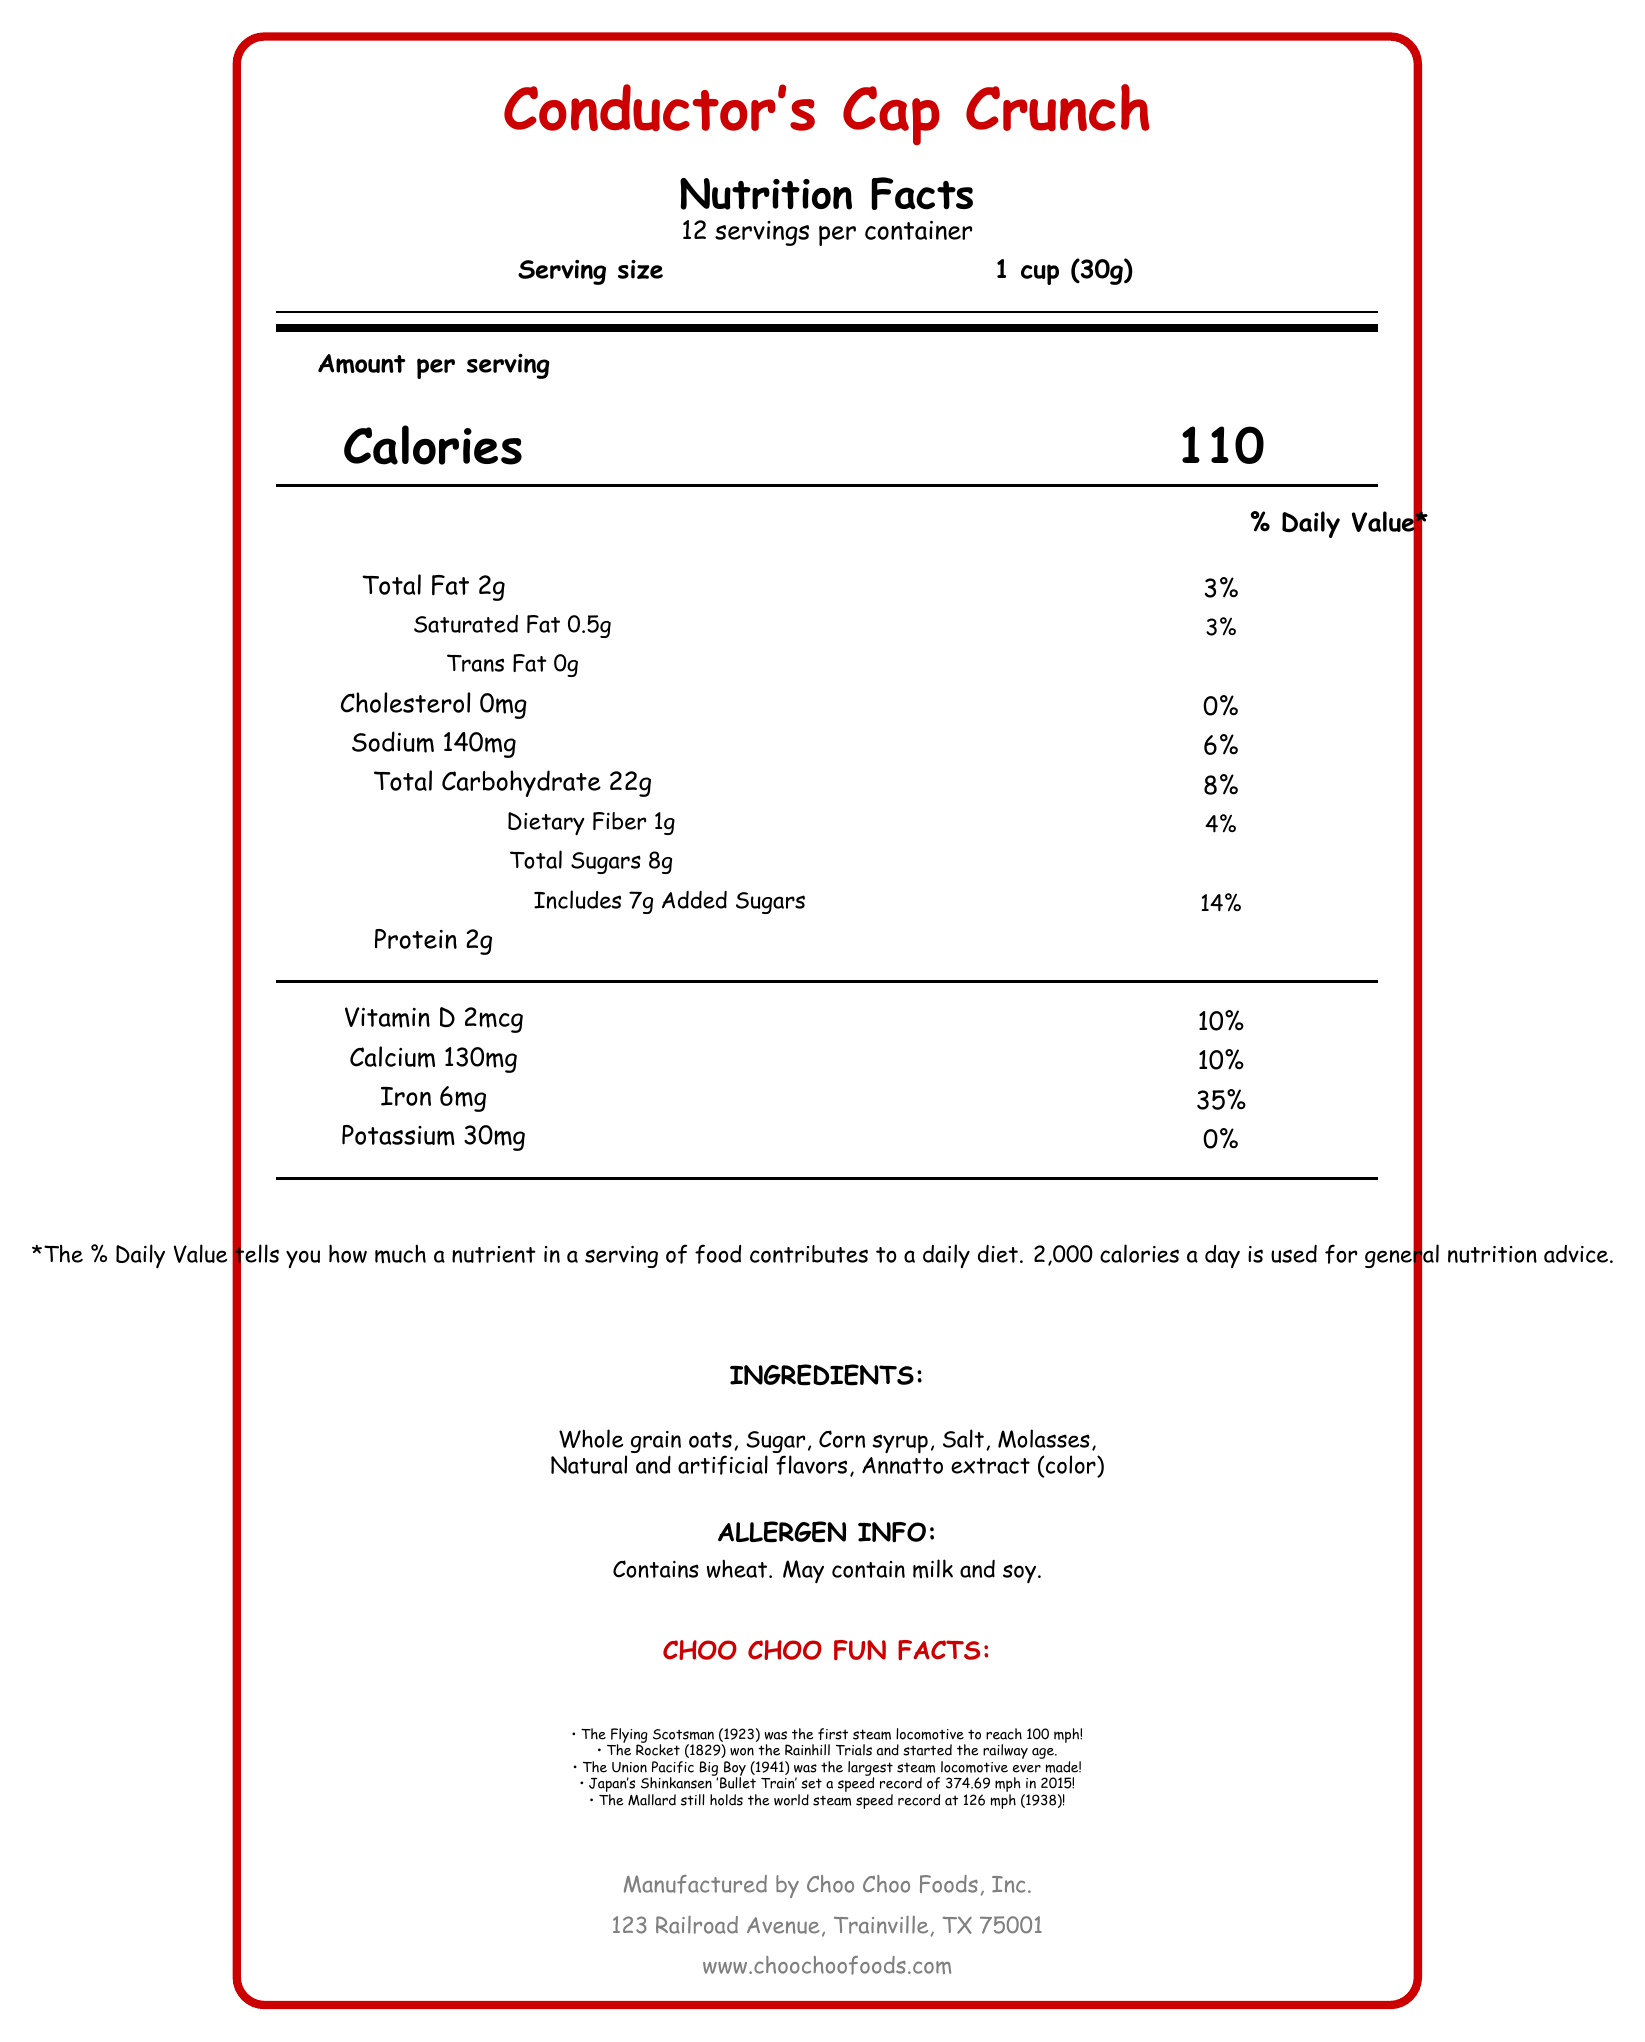what is the serving size? The serving size is listed as "1 cup (30g)" near the top of the nutrition facts section.
Answer: 1 cup (30g) how many calories are there per serving? It states "Calories 110" in large, bold letters to the right of "Amount per serving".
Answer: 110 how much total fat is in each serving? Total fat is listed as "Total Fat 2g" in the nutrition facts section.
Answer: 2g what percentage of the daily value is the sodium in each serving? Sodium is listed with a daily value percentage of "6%" in the nutrition facts section.
Answer: 6% how much dietary fiber is in one serving of the cereal? Dietary fiber is mentioned as "Dietary Fiber 1g" in the details under total carbohydrate.
Answer: 1g how much protein is there per serving? Protein is listed as "Protein 2g" in the nutrition facts section.
Answer: 2g what is a fun fact mentioned about The Flying Scotsman? The fun fact for The Flying Scotsman states that it was the first steam locomotive to reach 100 mph!
Answer: The Flying Scotsman was the first steam locomotive to reach 100 mph! what are the ingredient components of Conductor’s Cap Crunch? The ingredients section lists these components.
Answer: Whole grain oats, Sugar, Corn syrup, Salt, Molasses, Natural and artificial flavors, Annatto extract (color) how many servings are there per container? The document notes “12 servings per container” near the top of the nutrition facts section.
Answer: 12 how much added sugars does each serving contain? Added sugars are given as "Includes 7g Added Sugars" in the details under total sugars.
Answer: 7g does the product contain soy? The allergen information section states that it may contain soy.
Answer: May contain is this cereal high in added sugars? With 7g of added sugars per serving, which is 14% of the daily value, it can be considered relatively high.
Answer: Yes can you determine the exact manufacturing date of the cereal from the document? The document does not include a manufacturing date.
Answer: Cannot be determined summarize the main idea of the document. The document outlines the nutritional information for each serving, lists ingredients and possible allergens, includes fun facts about train history, and details the manufacturer's contact information.
Answer: The document is a nutrition facts label for "Conductor's Cap Crunch" cereal, including details on serving size, calories, nutrients, ingredients, and allergen information. Additionally, it provides fun facts about historic locomotives and information about the manufacturer. 